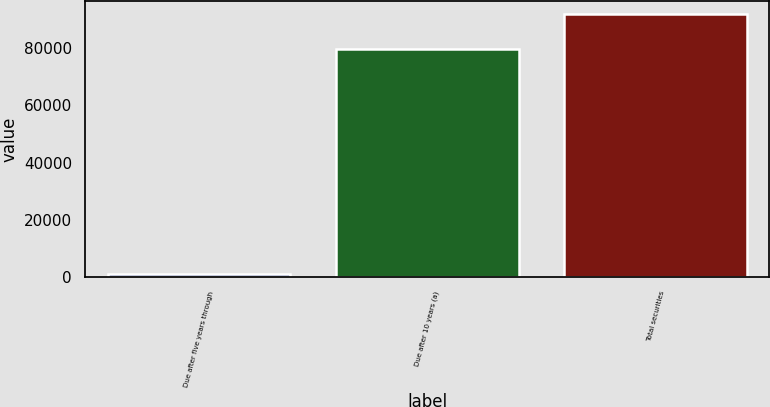Convert chart to OTSL. <chart><loc_0><loc_0><loc_500><loc_500><bar_chart><fcel>Due after five years through<fcel>Due after 10 years (a)<fcel>Total securities<nl><fcel>1211<fcel>79636<fcel>91917<nl></chart> 